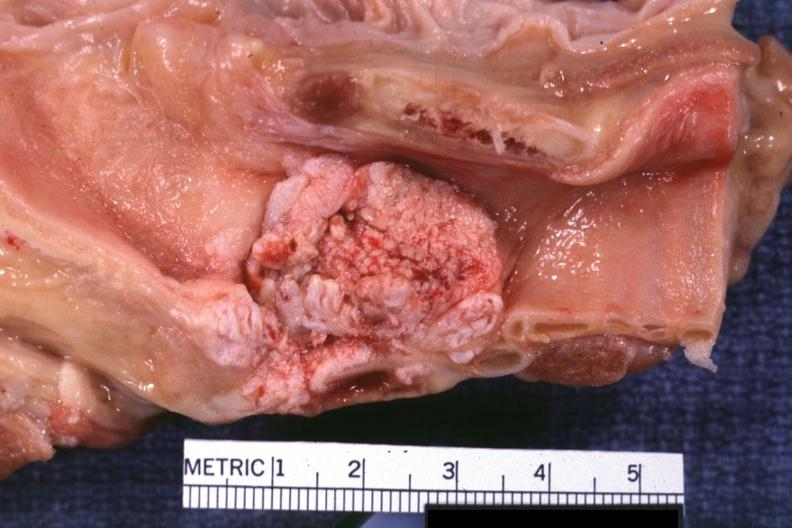s carcinoma present?
Answer the question using a single word or phrase. Yes 